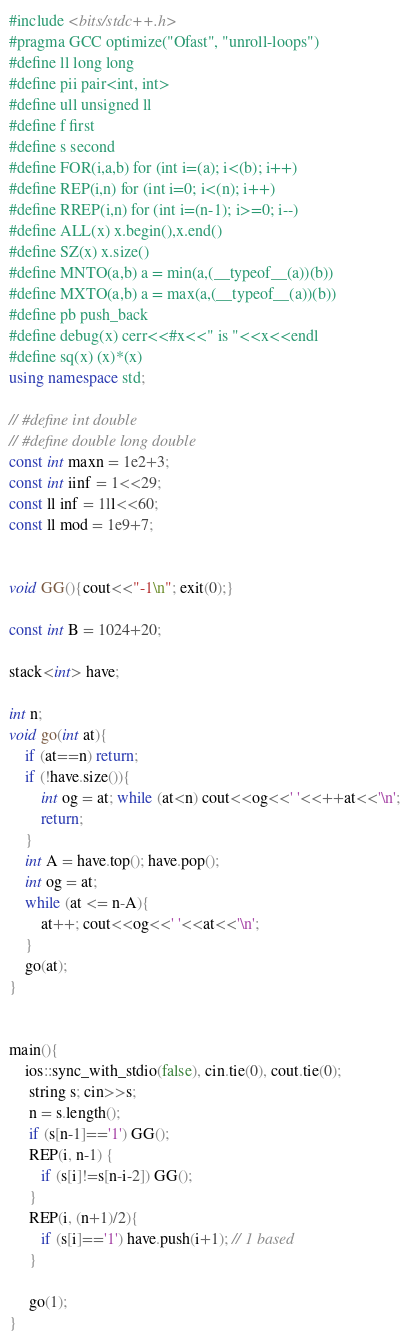Convert code to text. <code><loc_0><loc_0><loc_500><loc_500><_C++_>#include <bits/stdc++.h>
#pragma GCC optimize("Ofast", "unroll-loops")
#define ll long long 
#define pii pair<int, int>
#define ull unsigned ll
#define f first
#define s second
#define FOR(i,a,b) for (int i=(a); i<(b); i++)
#define REP(i,n) for (int i=0; i<(n); i++)
#define RREP(i,n) for (int i=(n-1); i>=0; i--)
#define ALL(x) x.begin(),x.end()
#define SZ(x) x.size()
#define MNTO(a,b) a = min(a,(__typeof__(a))(b))
#define MXTO(a,b) a = max(a,(__typeof__(a))(b))
#define pb push_back
#define debug(x) cerr<<#x<<" is "<<x<<endl
#define sq(x) (x)*(x)
using namespace std;

// #define int double
// #define double long double
const int maxn = 1e2+3;
const int iinf = 1<<29;
const ll inf = 1ll<<60;
const ll mod = 1e9+7;


void GG(){cout<<"-1\n"; exit(0);}

const int B = 1024+20;

stack<int> have;

int n;
void go(int at){
    if (at==n) return;
    if (!have.size()){
        int og = at; while (at<n) cout<<og<<' '<<++at<<'\n';
        return;
    }
    int A = have.top(); have.pop();
    int og = at;
    while (at <= n-A){
        at++; cout<<og<<' '<<at<<'\n';
    }
    go(at);
}


main(){
    ios::sync_with_stdio(false), cin.tie(0), cout.tie(0);
     string s; cin>>s;
     n = s.length();
     if (s[n-1]=='1') GG();
     REP(i, n-1) {
        if (s[i]!=s[n-i-2]) GG();
     }
     REP(i, (n+1)/2){
        if (s[i]=='1') have.push(i+1); // 1 based
     }

     go(1);
}</code> 